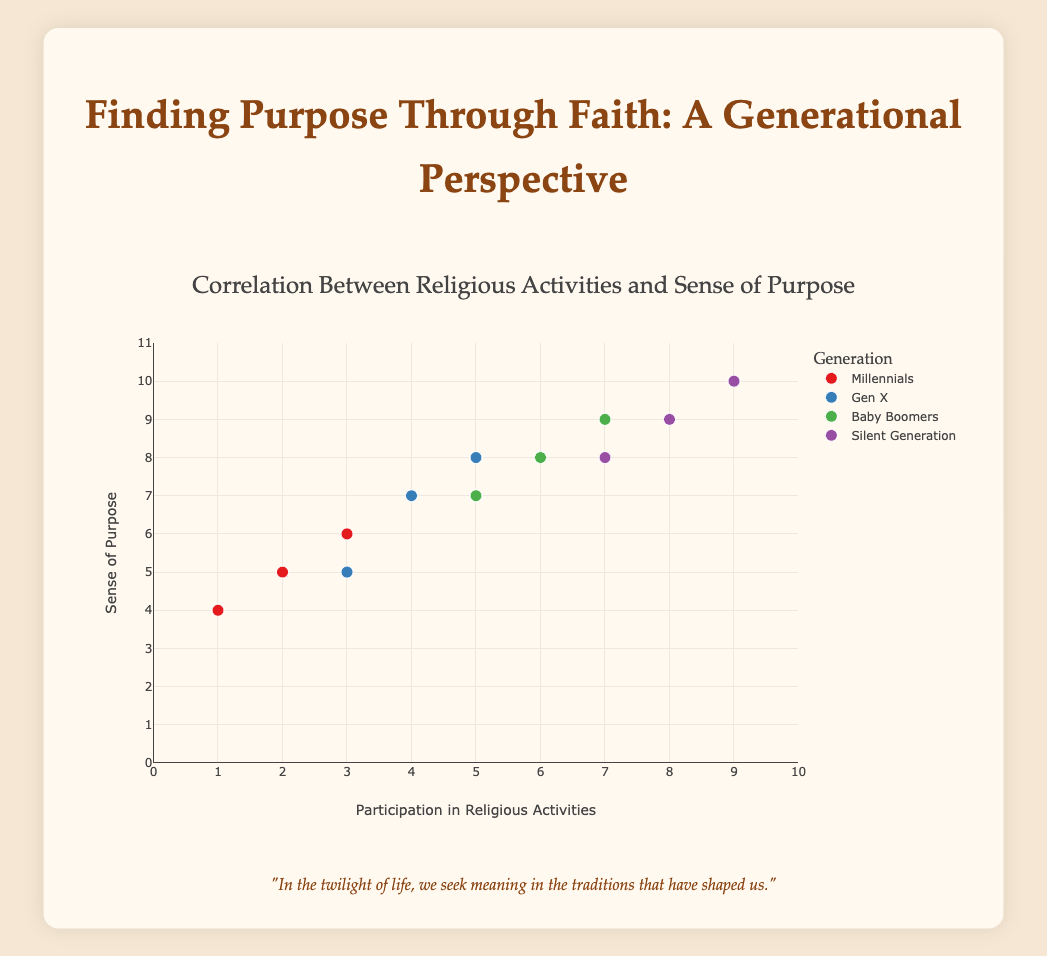What's the title of the figure? The title of the figure is prominently displayed at the top of the plot. It serves as a summary of the content and provides context for the viewer.
Answer: Correlation Between Religious Activities and Sense of Purpose Which age group appears to have both the highest participation in religious activities and the highest sense of purpose? By looking at the groups in the scattered plot, we can see the group with the highest values for both axes. The "65+" group (Silent Generation) reaches values of 9 for both religious activities and a sense of purpose.
Answer: Silent Generation (65+) What's the participation in religious activities for the highest sense of purpose value? First, identify the highest value on the y-axis (Sense of Purpose), which is 10. Then find the corresponding x-value (Religious Activities) for this data point.
Answer: 9 How many distinct age groups are represented in the plot? The legend or unique values in the grouping can help in identifying how many different groups are included. The plot features: Millennials, Gen X, Baby Boomers, and Silent Generation.
Answer: Four Which age group shows the widest range of values in terms of a sense of purpose? Compare the range (difference between maximum and minimum values) of Sense of Purpose for each group. Millennials range from 4 to 6, Gen X from 5 to 8, Baby Boomers from 7 to 9, and Silent Generation from 8 to 10. Gen X has the widest range from 5 to 8.
Answer: Gen X Are there any age groups where higher participation in religious activities does not correlate with a higher sense of purpose? Check each group's scattered distribution. Gen X shows one data point where religious activities are at 3, but the sense of purpose is at 5, which does not follow the increasing trend.
Answer: Gen X What is the average sense of purpose for Baby Boomers? Sum the sense of purpose values for Baby Boomers (8 + 7 + 9) and divide by the number of data points (3). The calculation is (8 + 7 + 9)/3 = 8.
Answer: 8 Compare the relationship between religious activities and sense of purpose for Millennials and the Silent Generation. Looking at both groups on the scatter plot, Millennials have a more varied relationship with less obvious correlation, ranging from 1-3 in religious activities and 4-6 in the sense of purpose. Silent Generation shows a strong positive correlation, with all values in higher ranges (7-9 for both axes).
Answer: Silent Generation has a stronger correlation Which group generally has a higher sense of purpose, Gen X or Baby Boomers? Compare the y-axis values (Sense of Purpose) of the two groups. Baby Boomers consistently have higher values, 7 to 9, compared to Gen X which ranges from 5 to 8.
Answer: Baby Boomers What is the median participation in religious activities for the Silent Generation? List the participation values (7, 8, 9) and find the middle value, which represents the median. Since there are three data points, the second value is the median.
Answer: 8 